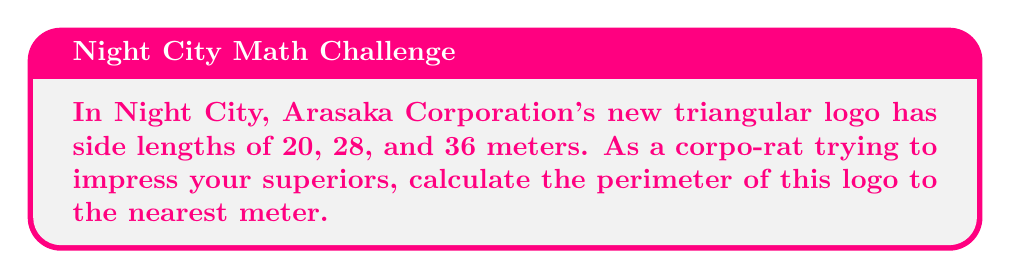Solve this math problem. Let's approach this step-by-step:

1) The perimeter of a triangle is the sum of its three sides.

2) We are given the following side lengths:
   Side 1: $20$ meters
   Side 2: $28$ meters
   Side 3: $36$ meters

3) To calculate the perimeter, we simply add these lengths:

   $$\text{Perimeter} = 20 + 28 + 36$$

4) Performing the addition:

   $$\text{Perimeter} = 84 \text{ meters}$$

5) The question asks for the answer to the nearest meter, but our result is already a whole number, so no rounding is necessary.

[asy]
unitsize(4mm);
pair A = (0,0), B = (9,0), C = (4.5,7.79);
draw(A--B--C--cycle);
label("20", (A+C)/2, NW);
label("28", (B+C)/2, NE);
label("36", (A+B)/2, S);
label("A", A, SW);
label("B", B, SE);
label("C", C, N);
[/asy]
Answer: 84 meters 